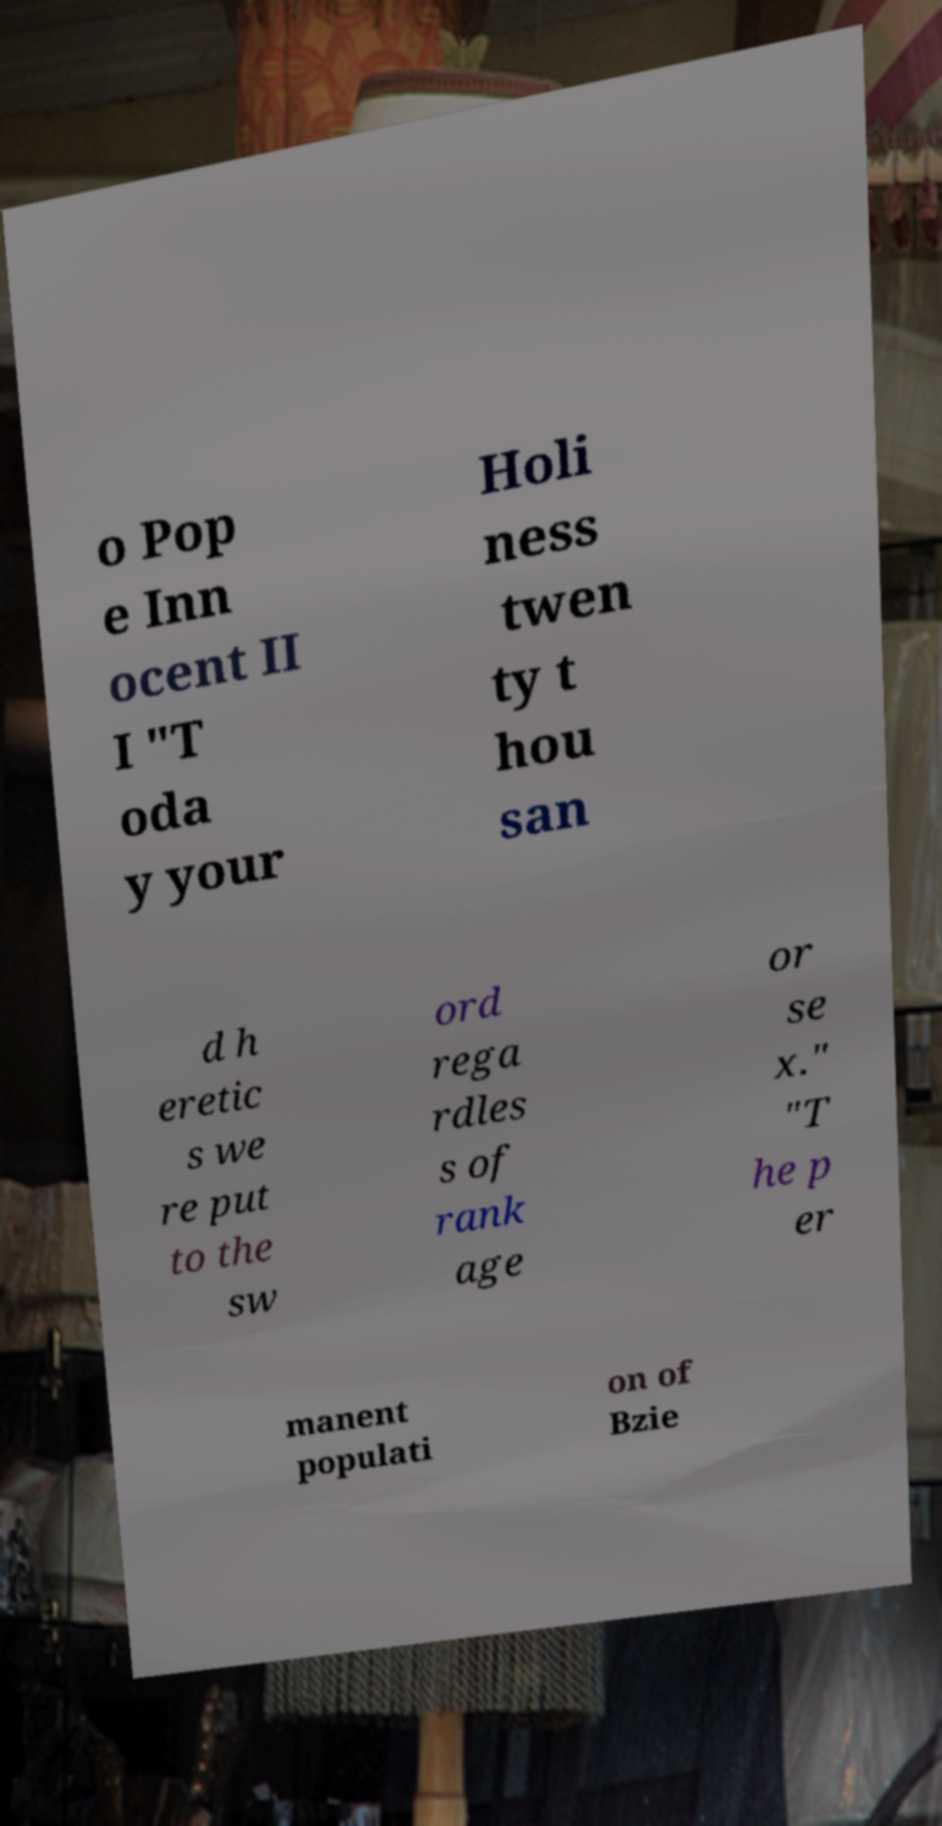Can you accurately transcribe the text from the provided image for me? o Pop e Inn ocent II I "T oda y your Holi ness twen ty t hou san d h eretic s we re put to the sw ord rega rdles s of rank age or se x." "T he p er manent populati on of Bzie 